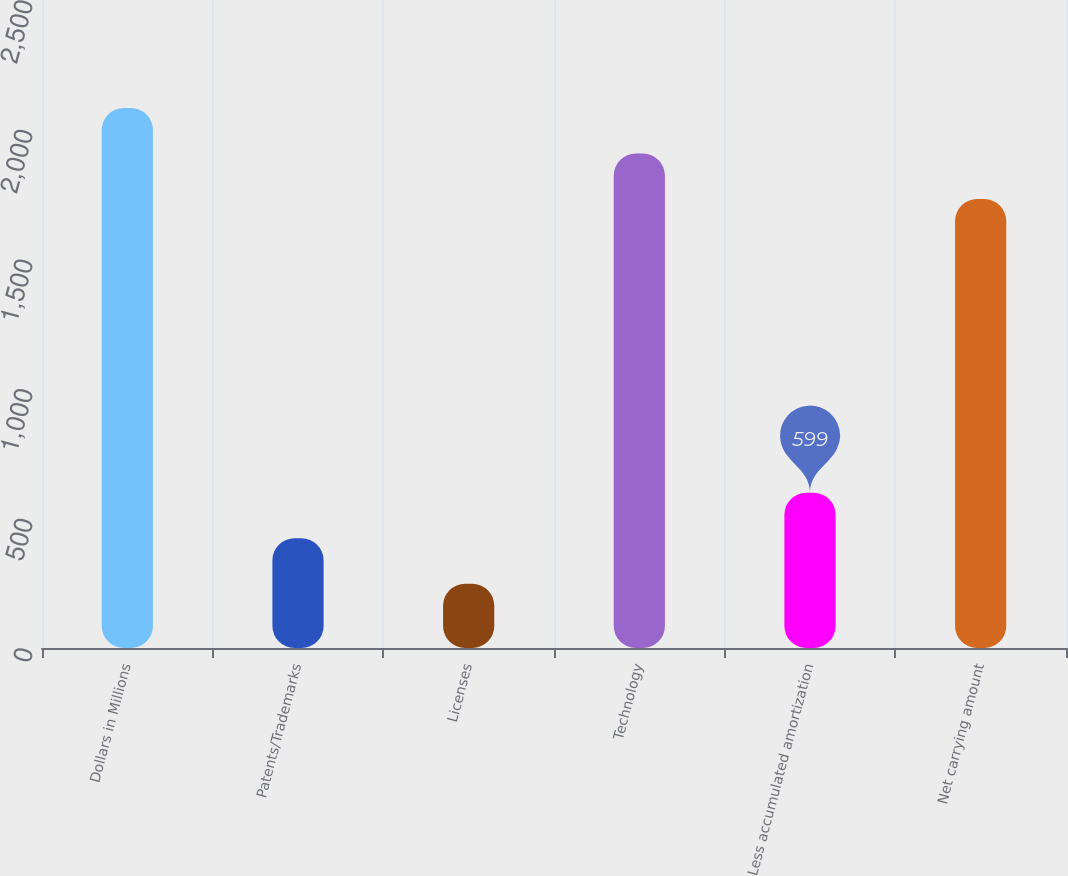<chart> <loc_0><loc_0><loc_500><loc_500><bar_chart><fcel>Dollars in Millions<fcel>Patents/Trademarks<fcel>Licenses<fcel>Technology<fcel>Less accumulated amortization<fcel>Net carrying amount<nl><fcel>2083<fcel>423.5<fcel>248<fcel>1907.5<fcel>599<fcel>1732<nl></chart> 